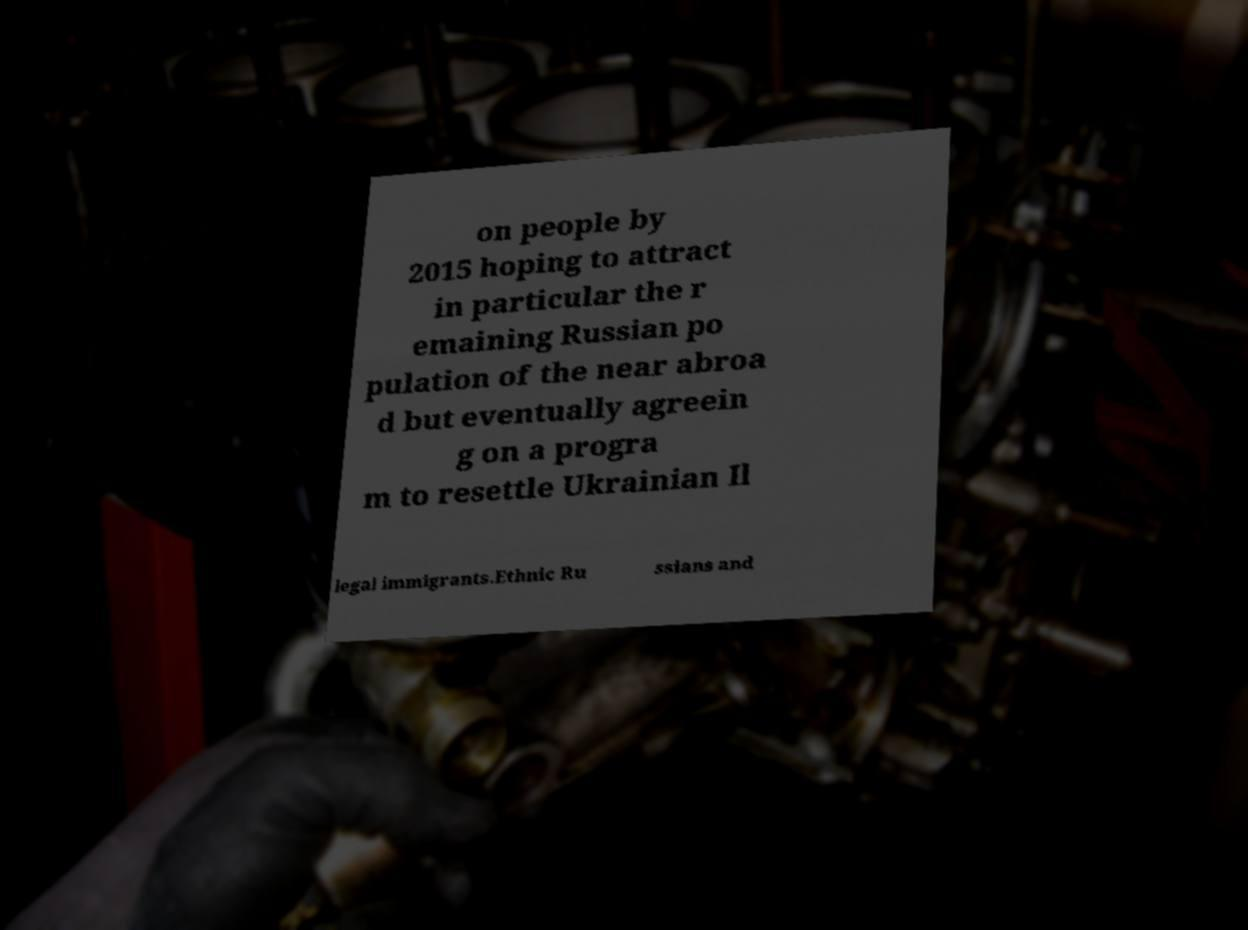Please identify and transcribe the text found in this image. on people by 2015 hoping to attract in particular the r emaining Russian po pulation of the near abroa d but eventually agreein g on a progra m to resettle Ukrainian Il legal immigrants.Ethnic Ru ssians and 